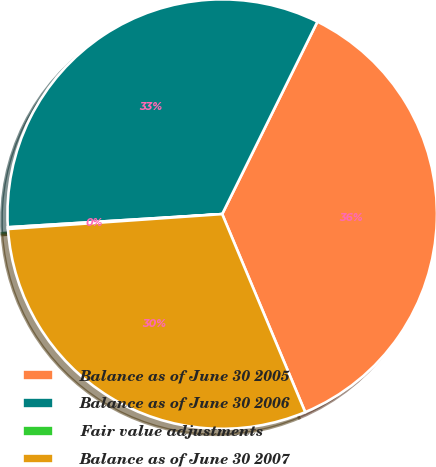<chart> <loc_0><loc_0><loc_500><loc_500><pie_chart><fcel>Balance as of June 30 2005<fcel>Balance as of June 30 2006<fcel>Fair value adjustments<fcel>Balance as of June 30 2007<nl><fcel>36.37%<fcel>33.29%<fcel>0.13%<fcel>30.21%<nl></chart> 